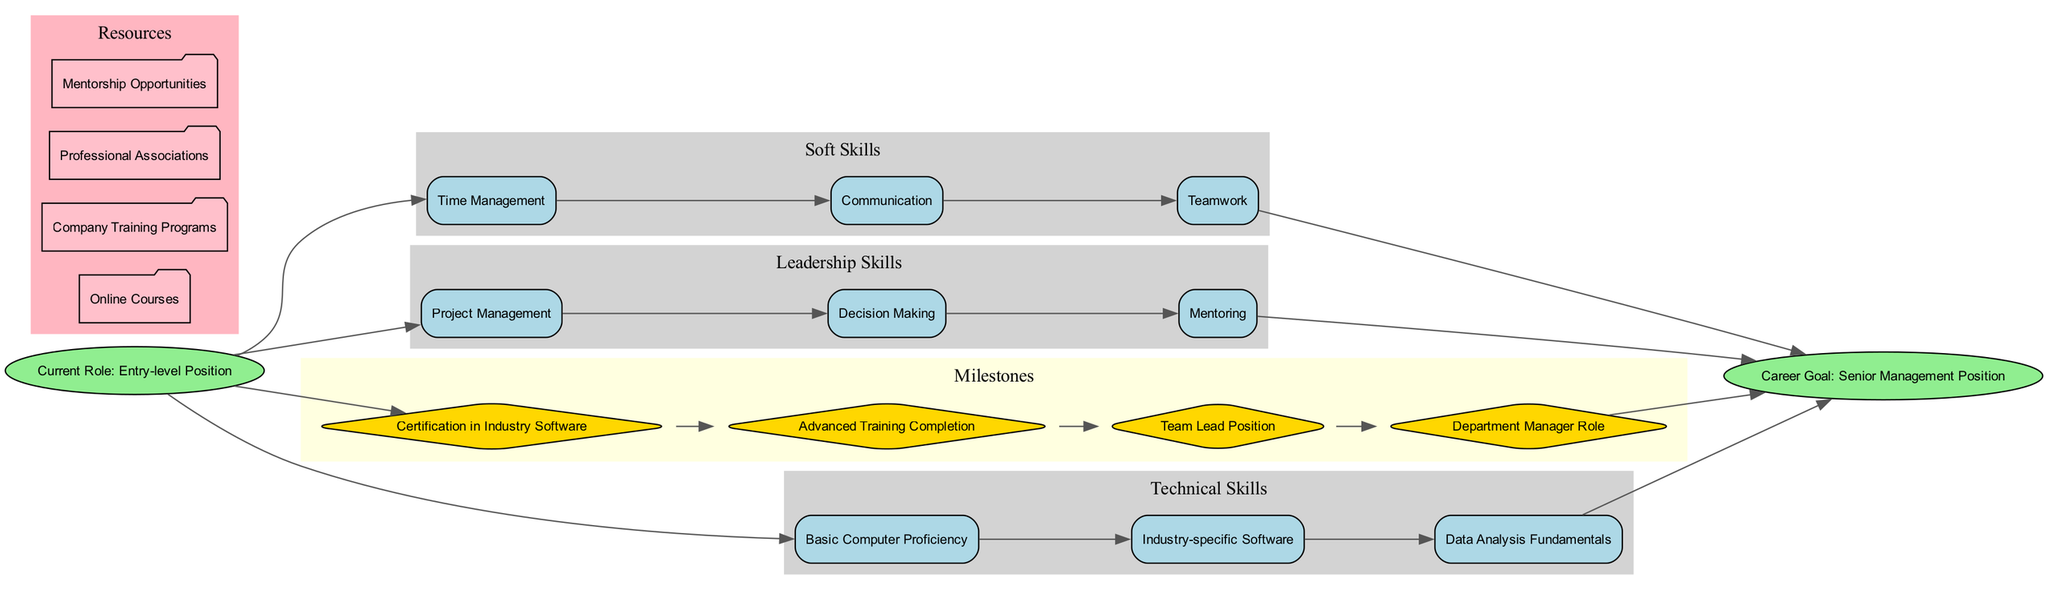What is the starting node of the diagram? The starting node is labeled "Current Role: Entry-level Position." This is directly identified in the diagram as the initial point where the skill development roadmap begins.
Answer: Current Role: Entry-level Position How many skill tracks are represented in the diagram? There are three skill tracks displayed in the diagram: "Technical Skills," "Soft Skills," and "Leadership Skills." By counting the distinct clusters, we can determine that there are three.
Answer: 3 What is the last milestone before reaching the career goal? The last milestone listed before the end node is "Department Manager Role," which signifies the final step before achieving the career goal of becoming a Senior Management Position.
Answer: Department Manager Role Which skill is located at the top of the "Soft Skills" track? The first skill listed under the "Soft Skills" track is "Time Management," making it the top skill in that particular category.
Answer: Time Management What type of resources are categorized in the diagram? The resources noted in the diagram include "Online Courses," "Company Training Programs," "Professional Associations," and "Mentorship Opportunities." These are grouped in the "Resources" cluster.
Answer: Online Courses, Company Training Programs, Professional Associations, Mentorship Opportunities What is required to become a Team Lead Position? Achieving the "Team Lead Position" milestone requires progressing through the skill tracks and completing the earlier milestones, specifically obtaining "Certification in Industry Software" and "Advanced Training Completion."
Answer: Certification in Industry Software, Advanced Training Completion What is the relationship between entry-level position and senior management position? The diagram depicts a progression from the "Current Role: Entry-level Position" to the "Career Goal: Senior Management Position," with multiple skill tracks and milestones serving as pathways that connect these two nodes.
Answer: Progression through skill tracks and milestones How many skills are listed under "Technical Skills"? There are three skills listed under the "Technical Skills" track: "Basic Computer Proficiency," "Industry-specific Software," and "Data Analysis Fundamentals." This is determined by counting the entries in that particular skill category.
Answer: 3 